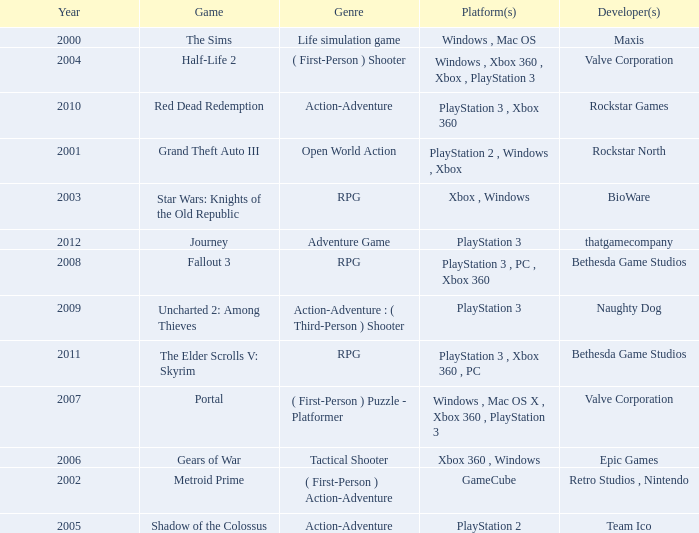What's the genre of The Sims before 2002? Life simulation game. 